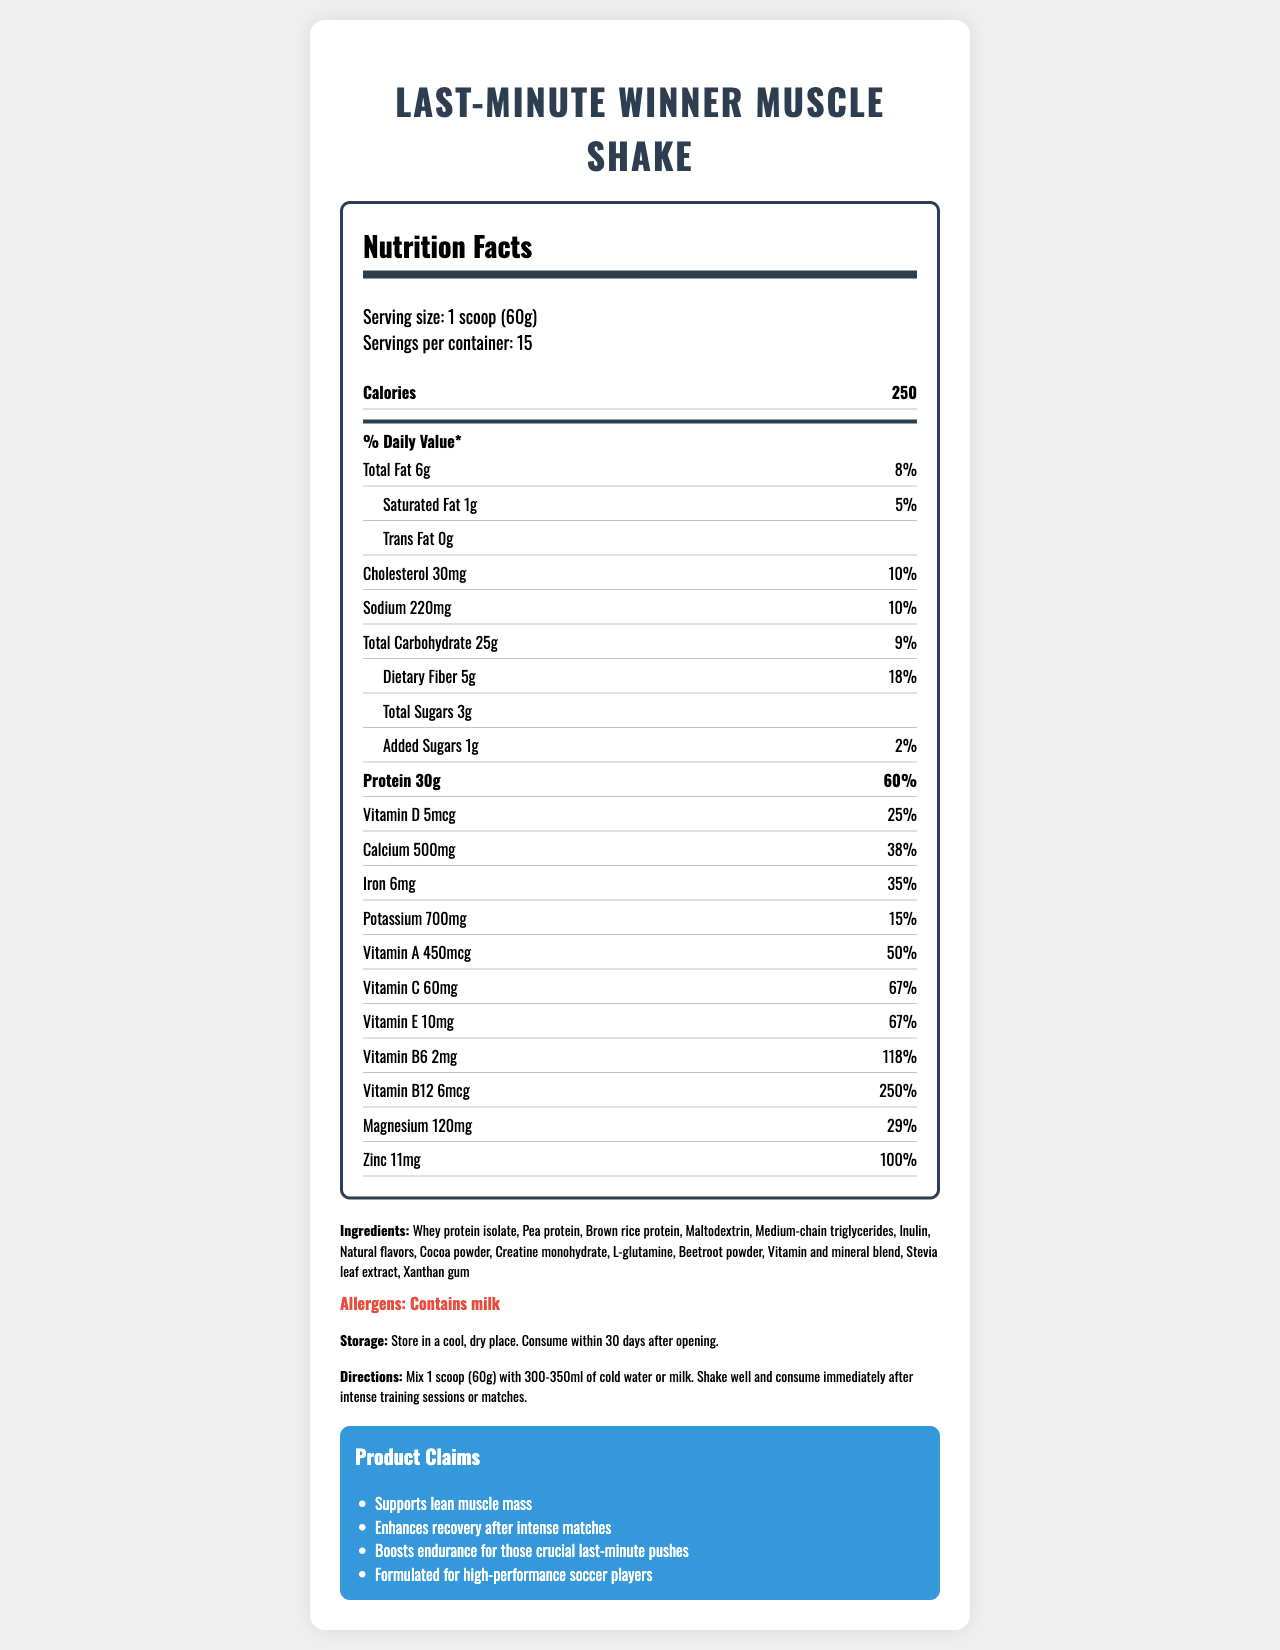what is the serving size of the Last-Minute Winner Muscle Shake? The serving size mentioned at the top of the label is 1 scoop (60g).
Answer: 1 scoop (60g) how many calories does one serving of the shake contain? The nutrition facts label specifies that one serving contains 250 calories.
Answer: 250 what percentage of the daily value for protein does one serving provide? According to the label, one serving provides 60% of the daily value for protein.
Answer: 60% which vitamins have the highest daily value percentages? The label states Vitamin B12 has a daily value of 250%, and Vitamin B6 has a daily value of 118%, which are the highest listed percentages.
Answer: Vitamin B12 and Vitamin B6 how much sugar is in the shake, including added sugars? The label specifically lists 3g of Total Sugars and 1g of Added Sugars.
Answer: 3g Total Sugars (1g Added Sugars) how many servings are there per container? The serving information indicates there are 15 servings per container.
Answer: 15 what is the amount of calcium in one serving? A. 500mg B. 6mg C. 220mg D. 120mg The label clearly states that one serving contains 500mg of calcium.
Answer: A which ingredient is listed first in the ingredients list? According to the ingredients list, Whey protein isolate is listed first.
Answer: Whey protein isolate does the product contain any common allergens? The allergens section mentions that the product contains milk.
Answer: Yes what are the storage instructions for the shake? The storage instructions are specified at the bottom of the label.
Answer: Store in a cool, dry place. Consume within 30 days after opening. is the Last-Minute Winner Muscle Shake designed to enhance recovery after intense matches? The product claims section states that it enhances recovery after intense matches.
Answer: Yes summarize the main idea of the Last-Minute Winner Muscle Shake Nutrition Facts Label. This summary captures the general purpose and key nutritional highlights mentioned in the document.
Answer: The Last-Minute Winner Muscle Shake is a nutrient-dense meal replacement designed for soccer players to support lean muscle mass, enhance recovery, and boost endurance. It provides detailed nutritional information, including high protein content and essential vitamins and minerals, along with storage and consumption instructions. which mineral has the lowest daily value percentage? A. Iron B. Calcium C. Sodium D. Potassium Potassium has a daily value of 15%, which is the lowest compared to Iron (35%), Calcium (38%), and Sodium (10%).
Answer: D how many grams of dietary fiber are in each serving? The label lists 5g of dietary fiber per serving.
Answer: 5g is creatine monohydrate one of the ingredients? Creatine monohydrate is listed in the ingredients section.
Answer: Yes what percentage of the daily value for total fat does one serving provide? The label states that one serving provides 8% of the daily value for total fat.
Answer: 8% how much vitamin D does one serving provide? One serving provides 5mcg of vitamin D according to the label.
Answer: 5mcg how long should the shake be consumed after intense training sessions or matches? The directions indicate that the shake should be consumed immediately after intense training sessions or matches.
Answer: Immediately what is the exact measurement of magnesium in the shake? The nutrition facts list magnesium content as 120mg per serving.
Answer: 120mg will this shake boost endurance for crucial last-minute pushes? The product claims state that the shake boosts endurance for those crucial last-minute pushes.
Answer: Yes does the nutrition label give details on shipping weight? The document provides nutrition facts but does not mention shipping weight.
Answer: Not enough information 